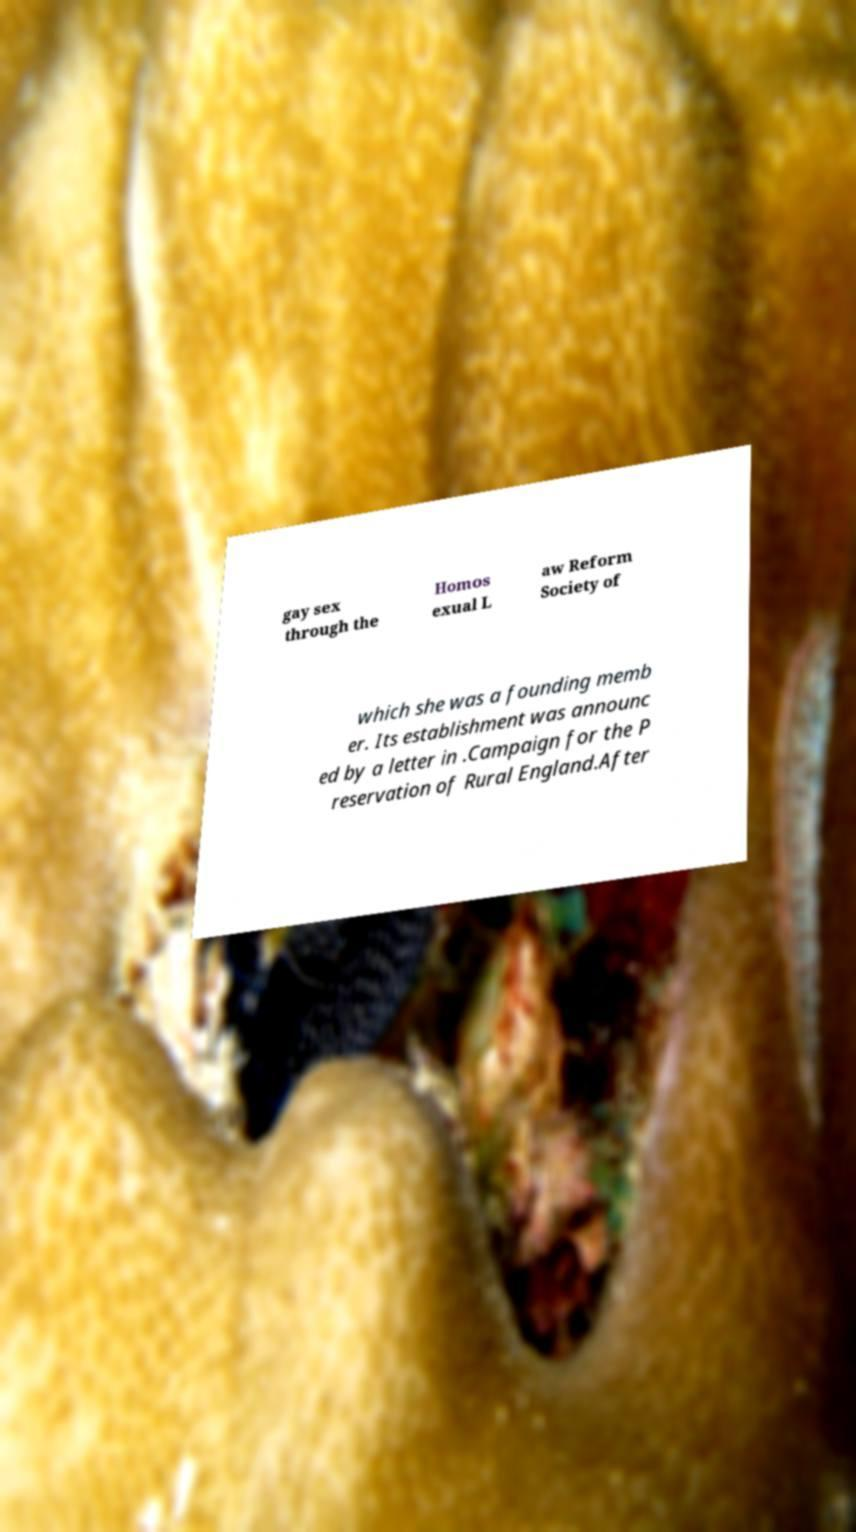There's text embedded in this image that I need extracted. Can you transcribe it verbatim? gay sex through the Homos exual L aw Reform Society of which she was a founding memb er. Its establishment was announc ed by a letter in .Campaign for the P reservation of Rural England.After 